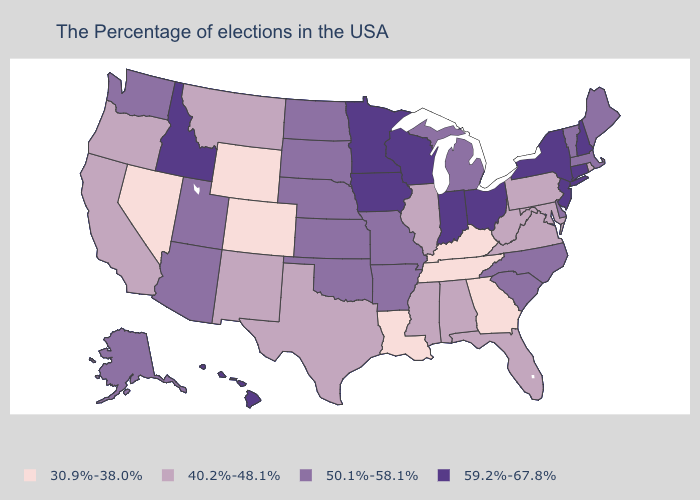Does Alaska have the lowest value in the USA?
Concise answer only. No. Does the map have missing data?
Give a very brief answer. No. Does Iowa have the highest value in the MidWest?
Give a very brief answer. Yes. What is the value of Pennsylvania?
Short answer required. 40.2%-48.1%. Among the states that border Vermont , does Massachusetts have the highest value?
Concise answer only. No. Among the states that border North Carolina , which have the lowest value?
Keep it brief. Georgia, Tennessee. Which states hav the highest value in the West?
Be succinct. Idaho, Hawaii. Which states hav the highest value in the Northeast?
Quick response, please. New Hampshire, Connecticut, New York, New Jersey. Name the states that have a value in the range 30.9%-38.0%?
Be succinct. Georgia, Kentucky, Tennessee, Louisiana, Wyoming, Colorado, Nevada. What is the value of Kentucky?
Keep it brief. 30.9%-38.0%. Name the states that have a value in the range 59.2%-67.8%?
Short answer required. New Hampshire, Connecticut, New York, New Jersey, Ohio, Indiana, Wisconsin, Minnesota, Iowa, Idaho, Hawaii. What is the value of Colorado?
Concise answer only. 30.9%-38.0%. Does North Carolina have the lowest value in the South?
Keep it brief. No. Does the first symbol in the legend represent the smallest category?
Quick response, please. Yes. Among the states that border Wyoming , does Idaho have the highest value?
Answer briefly. Yes. 